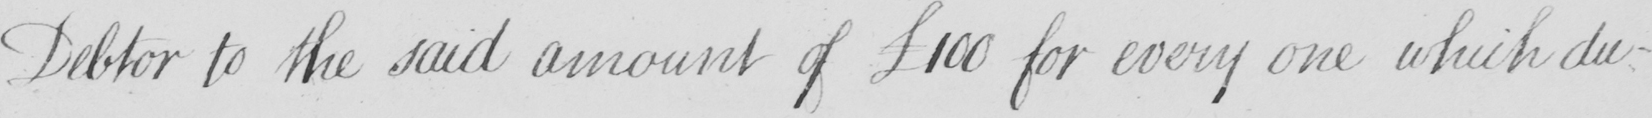What text is written in this handwritten line? Debtor to the said amount of  £100 for every one which du- 